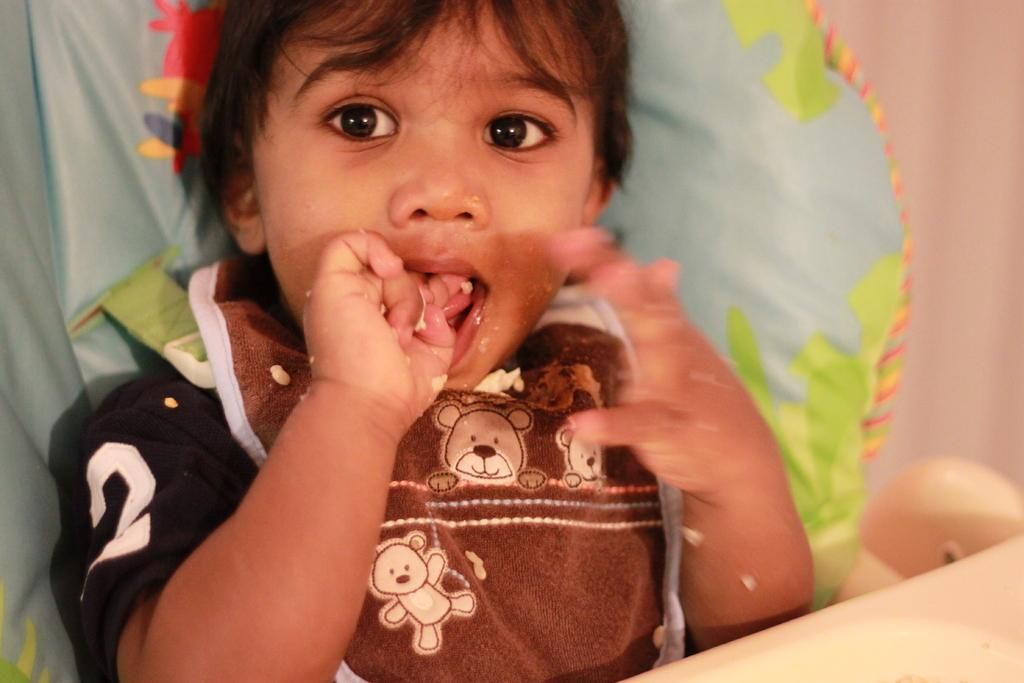What is the baby doing in the image? The baby is sitting in a baby chair and looking at a picture. What is the baby wearing in the image? The baby is wearing a t-shirt. How is the background of the image depicted? The background is blurred. What can be seen in the bottom right-hand corner of the image? There is an object in the bottom right-hand corner of the image. What type of laborer is depicted in the image? There is no laborer present in the image; it features a baby in a baby chair. What part of the brain can be seen in the image? There is no part of the brain visible in the image; it shows a baby looking at a picture. 